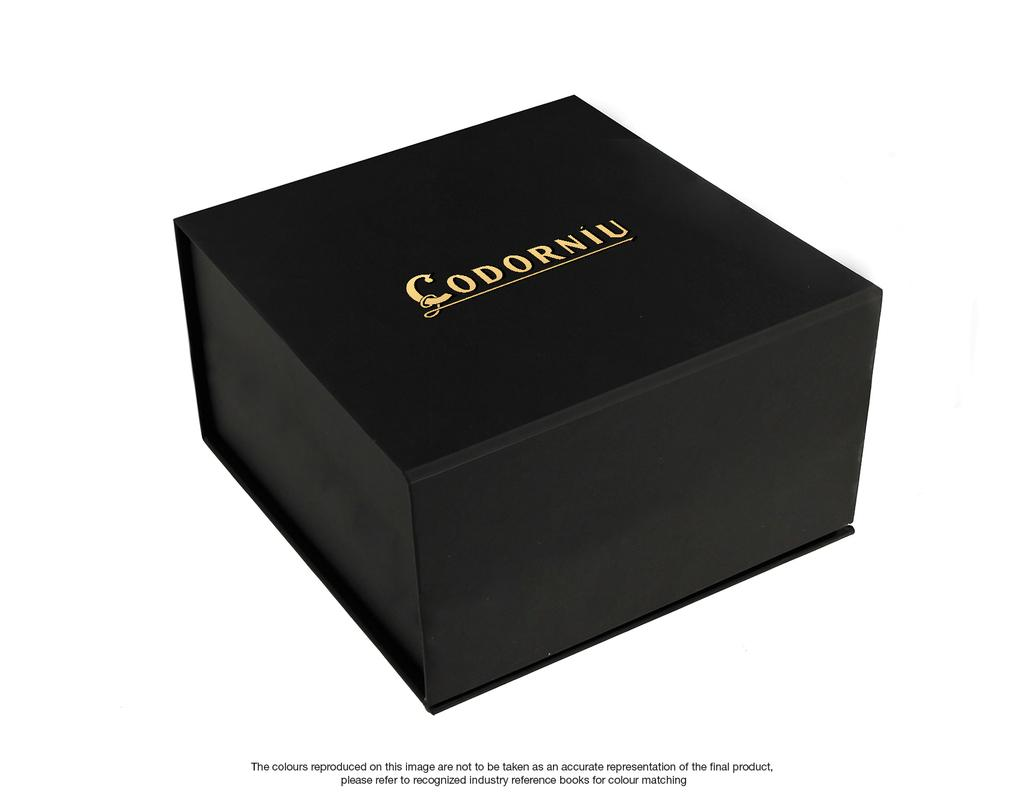<image>
Offer a succinct explanation of the picture presented. A black box that contains a Codorniu product 